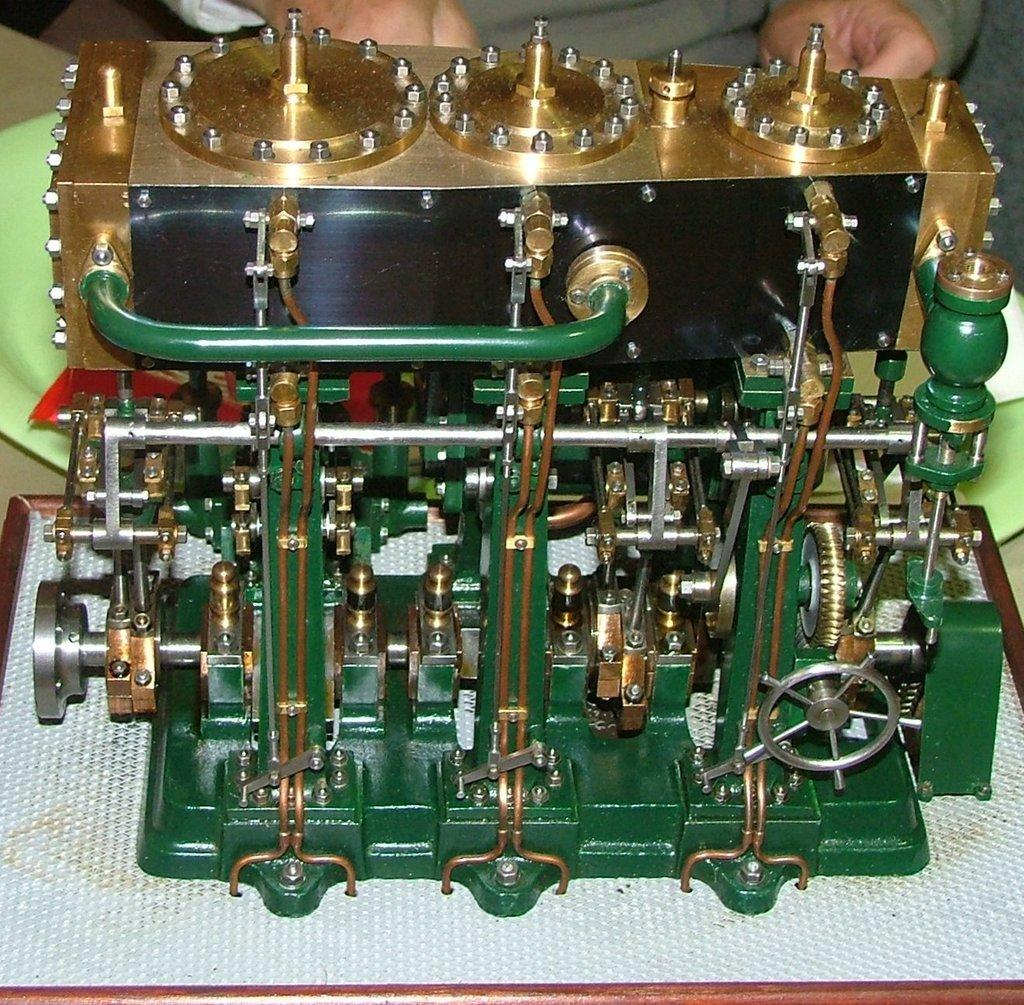What is the main subject in the image? There is a person standing in the image. What else can be seen in the image besides the person? There is a machine in the image. Can you describe the location of the machine in the image? The machine is on a white surface. What type of pear ornament is hanging from the ceiling in the image? There is no pear ornament hanging from the ceiling in the image; the provided facts do not mention any such object. 